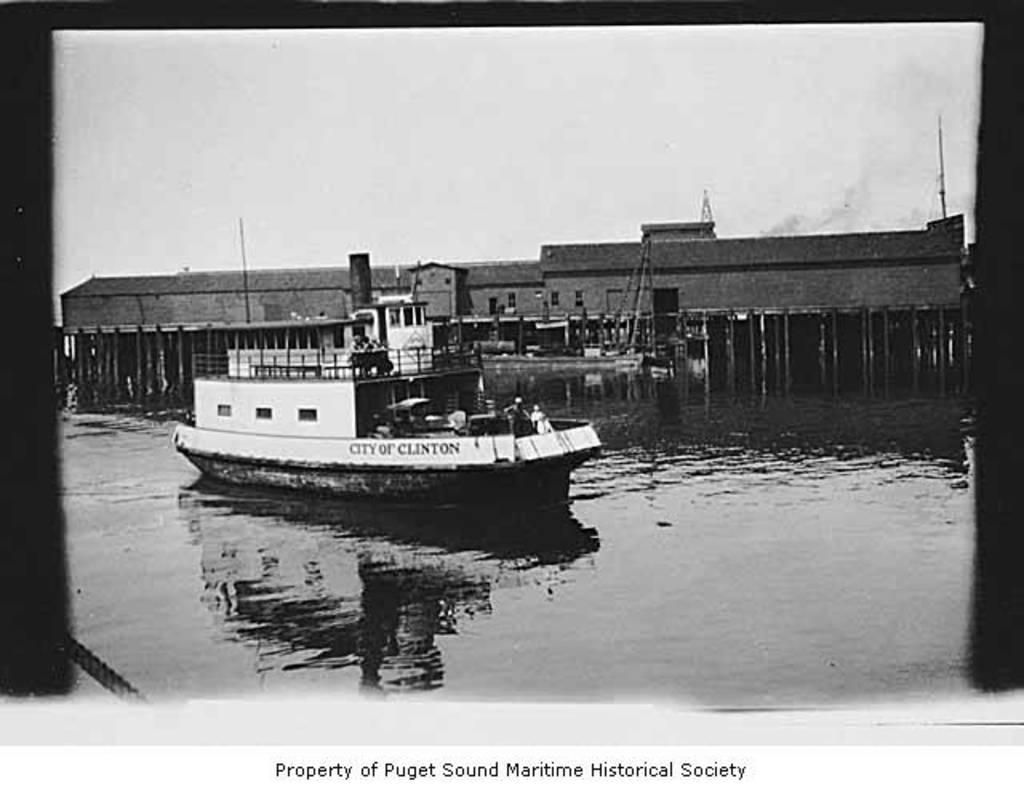What is featured on the poster in the image? The poster contains a white-colored boat. What can be seen at the bottom of the image? There is water at the bottom of the image. What is visible in the background of the image? There is a building in the background of the image. What is visible at the top of the image? The sky is visible at the top of the image. Can you tell me how many kittens are playing chess with the farmer in the image? There are no kittens or farmers present in the image. What type of chess pieces can be seen on the poster? There are no chess pieces visible on the poster; it features a white-colored boat. 